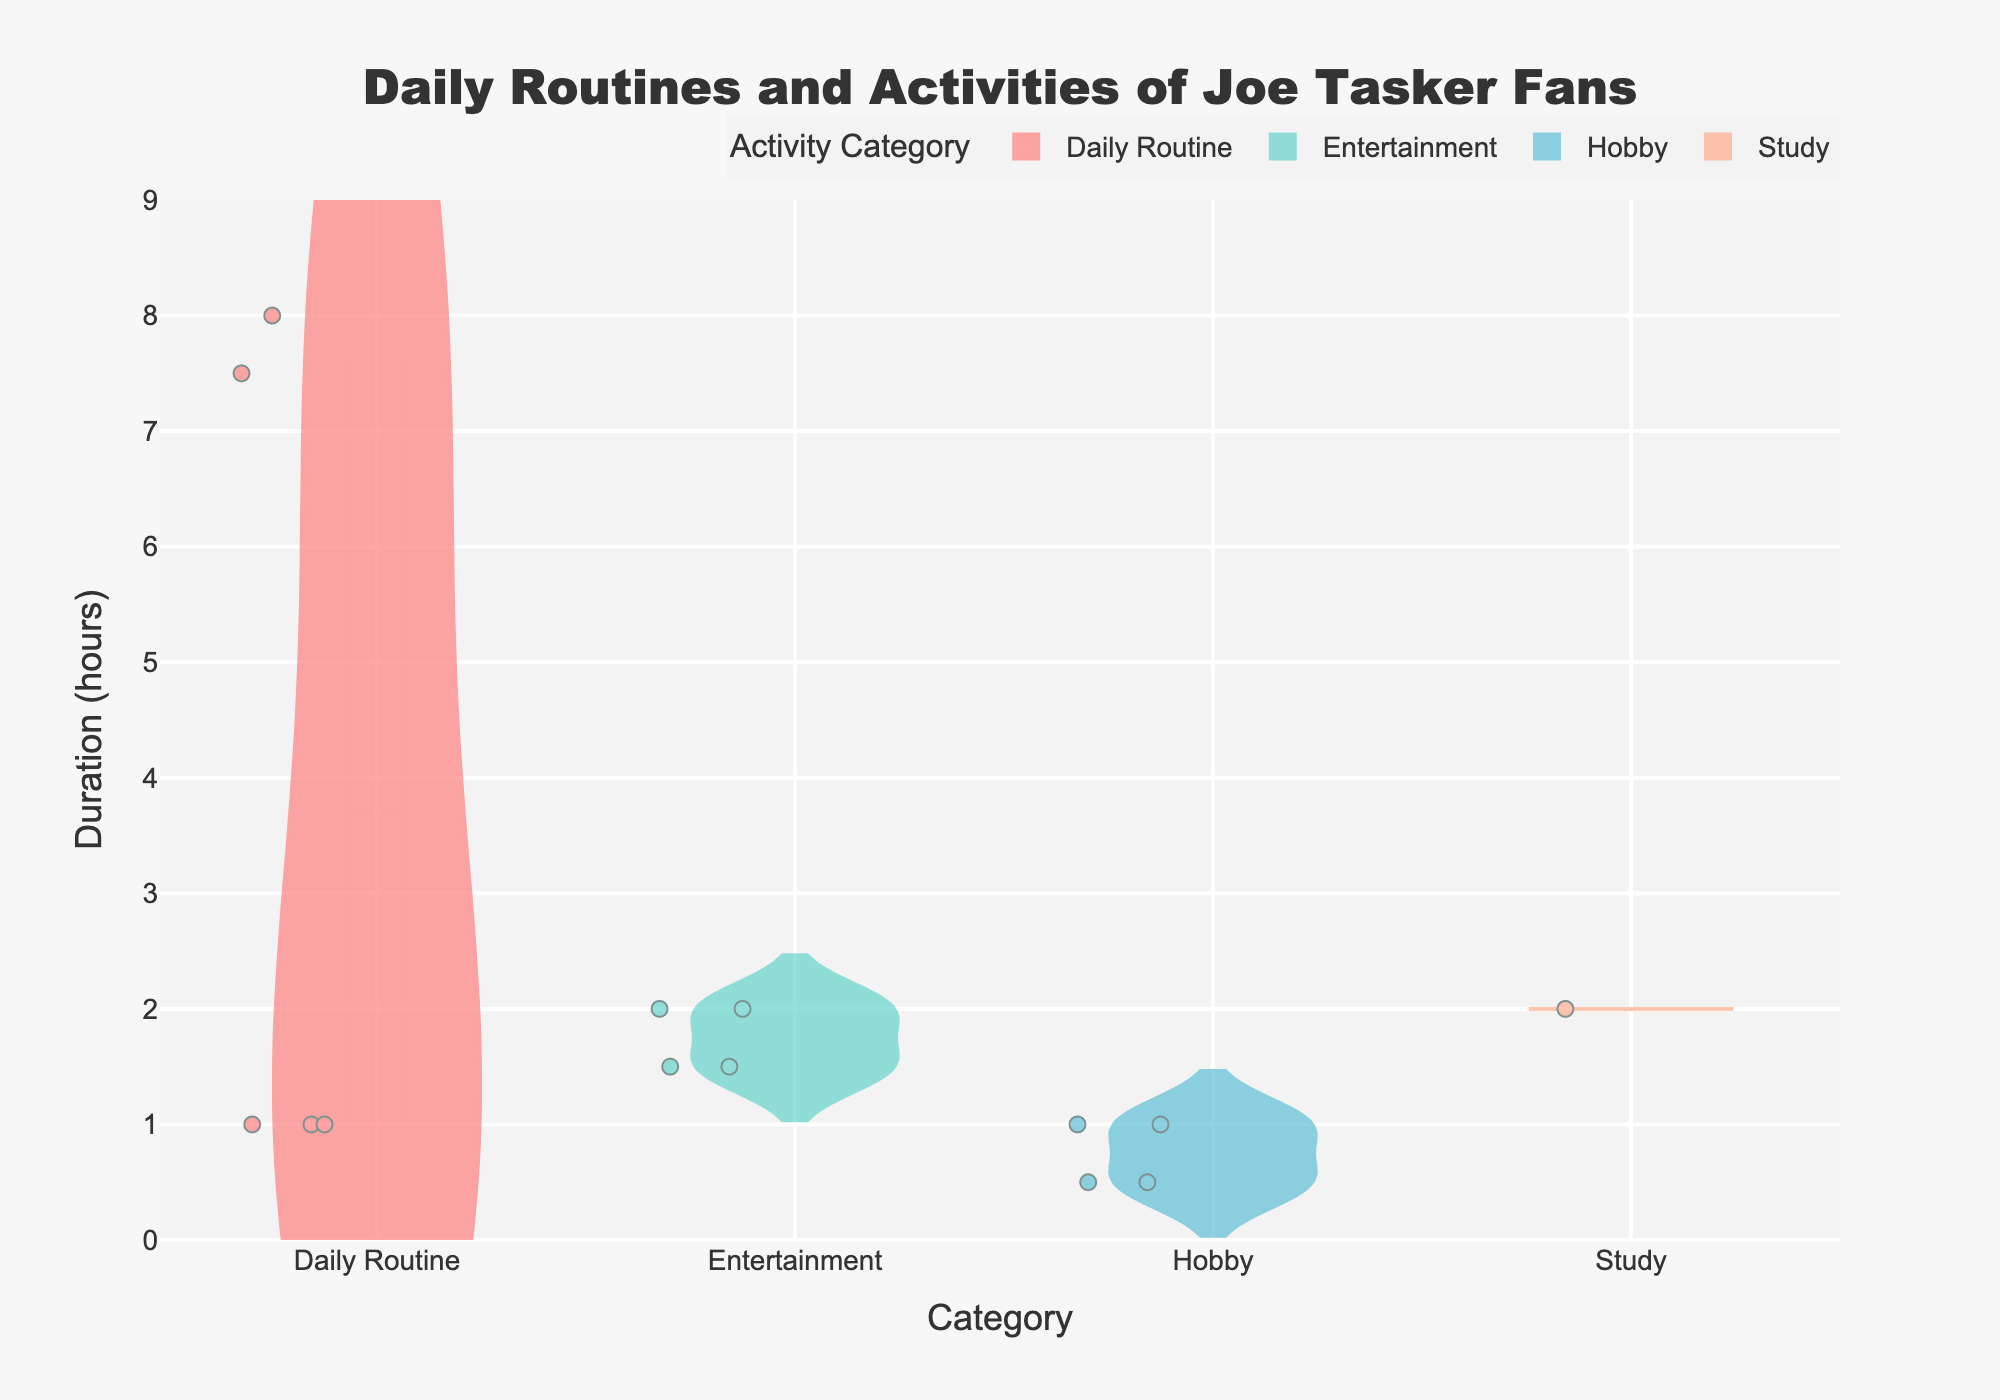What is the title of the figure? The title is usually located at the top of the figure. In this case, it reads "Daily Routines and Activities of Joe Tasker Fans."
Answer: Daily Routines and Activities of Joe Tasker Fans What are the categories shown on the x-axis? The x-axis represents different activity categories. Going from left to right, it includes "Daily Routine," "Entertainment," "Hobby," and "Study."
Answer: Daily Routine, Entertainment, Hobby, Study How much time do fans spend sleeping on average? The violin plot provides a mean line for each category. Locate the "Sleep" activity under "Daily Routine" and check the mean line for its duration.
Answer: 7.5 hours Which category has the widest range of activity durations? The width of the violin plot indicates the range of durations. Compare the widths across "Daily Routine," "Entertainment," "Hobby," and "Study."
Answer: Daily Routine What is the activity with the shortest duration? Look for the activity within each category that has the lowest point on the y-axis. "Reading" and "Meditation" both seem to have the smallest duration at 0.5 hours.
Answer: Reading, Meditation Which activity within the "Entertainment" category has the maximum duration? Examine the individual points and the spread in the "Entertainment" category. The highest point represents "Hanging out with friends" and is at 2 hours.
Answer: Hanging out with friends How many hours do fans spend on average commuting? The "Commute" activity falls under the "Daily Routine" category. The mean line specifically reveals this duration.
Answer: 1 hour How do the average hours spent on studying compare with watching Joe Tasker videos? Compare the position of the mean lines for "Studying" under "Study" and "Watching Joe Tasker Videos" under "Entertainment." Both are at 2 hours.
Answer: They are equal What is the average duration of activities in the "Hobby" category? Calculate the average duration by summing the mean lines for all activities under "Hobby" and dividing by the number of activities. (Exercise: 1, Reading: 0.5, Meditation: 0.5, Podcast Listening: 1).
Answer: 0.75 hours What is the range of durations for activities in the "Daily Routine" category? Look at the minimum and maximum points within the "Daily Routine" category. The minimum is 1 hour (Commute, House Chores, Cooking), and the maximum is 8 hours (Work).
Answer: 1 to 8 hours 